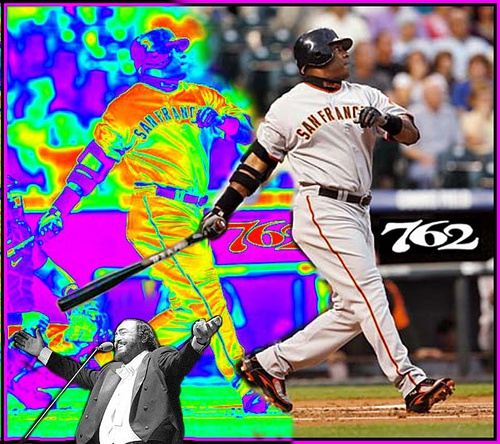Describe the objects in this image and their specific colors. I can see people in black, lightgray, darkgray, and gray tones, people in black, yellow, orange, red, and lime tones, people in black, gray, white, and darkgray tones, people in black, gray, and tan tones, and people in black, darkgray, lightpink, and gray tones in this image. 